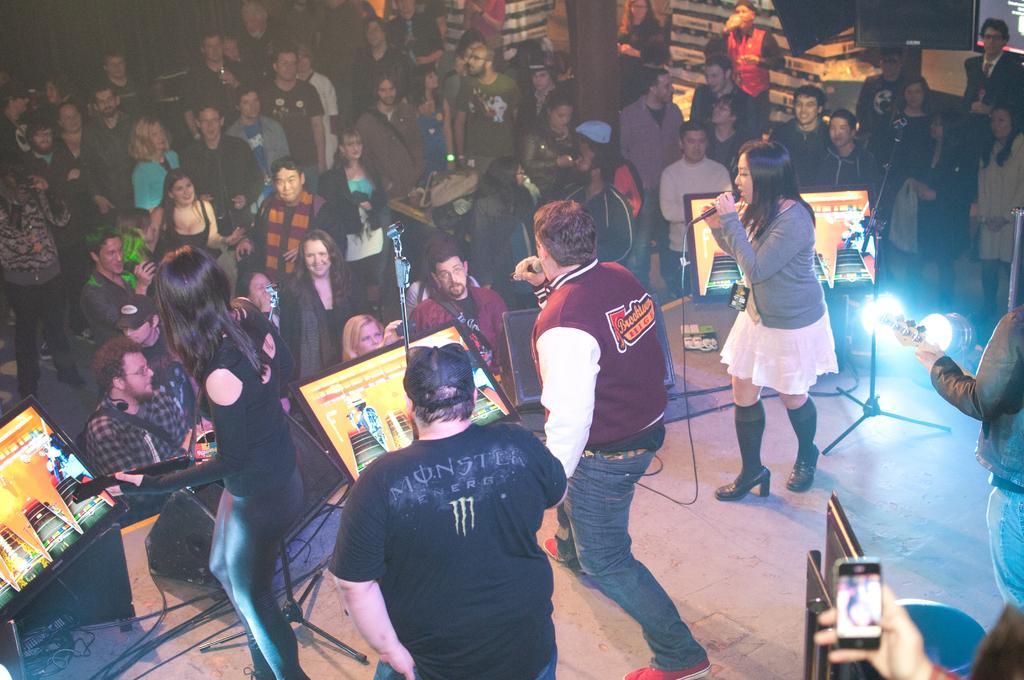Describe this image in one or two sentences. In this there are group of musicians performing at the stage and a group of people standing and watching at the concert. There are screens on the stage, spotlights. The women at the right side is holding a mic and singing. 